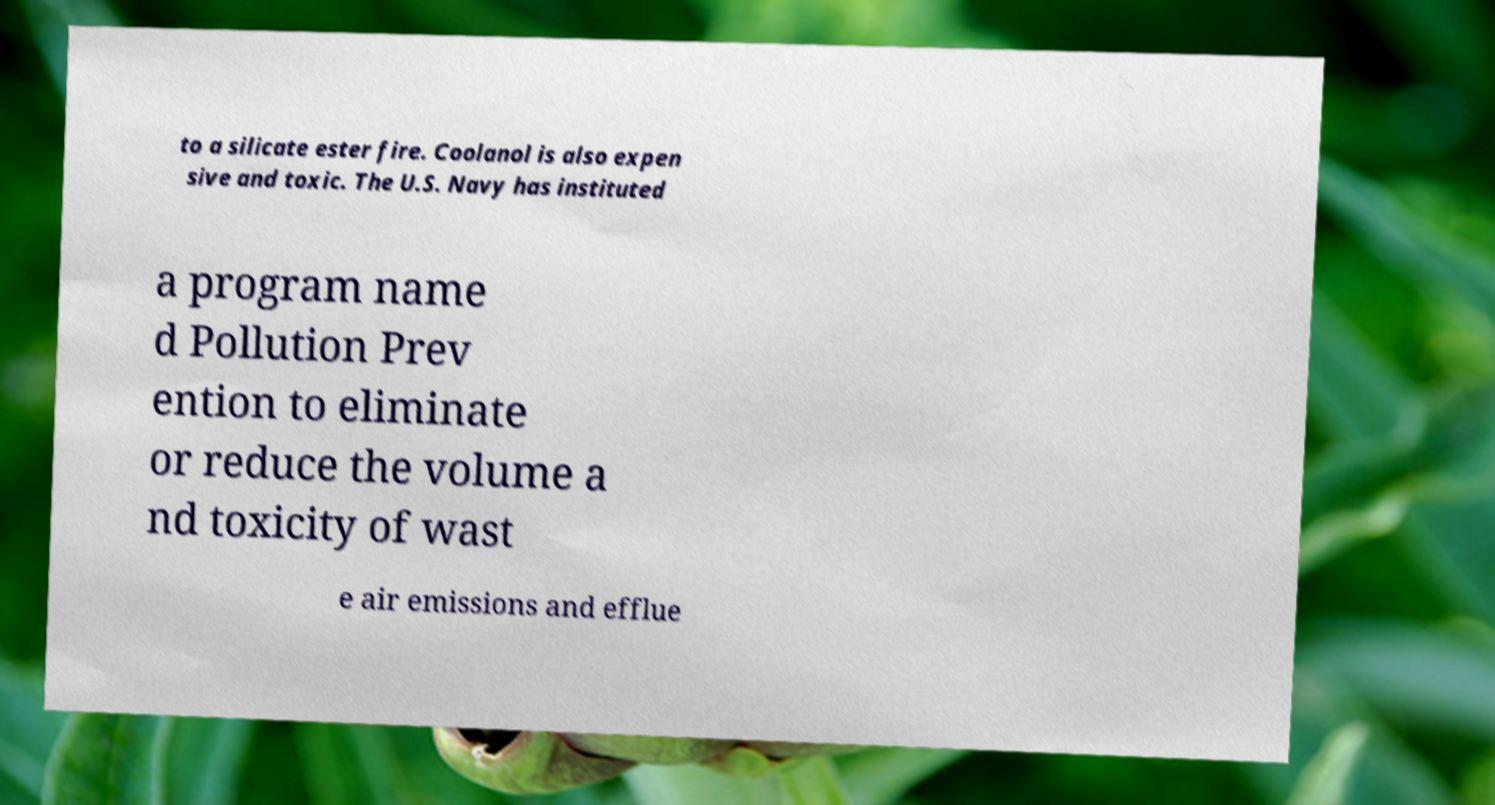What messages or text are displayed in this image? I need them in a readable, typed format. to a silicate ester fire. Coolanol is also expen sive and toxic. The U.S. Navy has instituted a program name d Pollution Prev ention to eliminate or reduce the volume a nd toxicity of wast e air emissions and efflue 